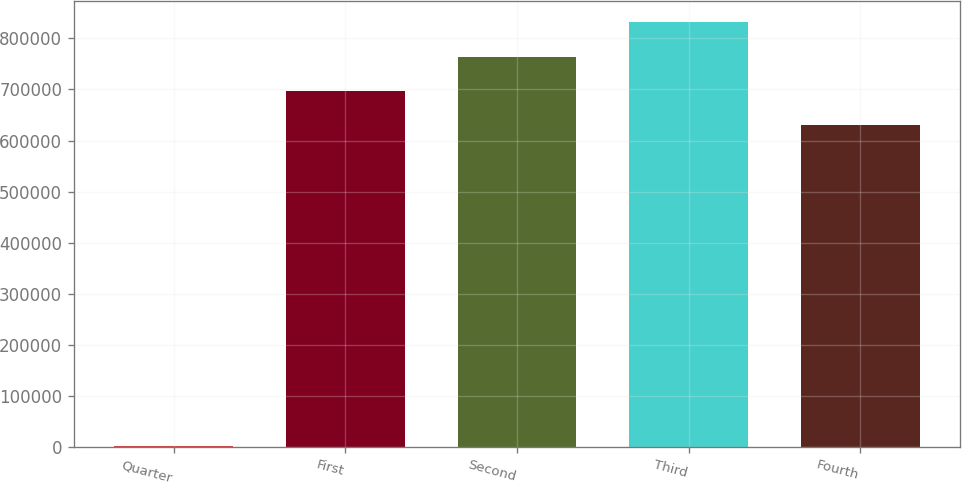Convert chart to OTSL. <chart><loc_0><loc_0><loc_500><loc_500><bar_chart><fcel>Quarter<fcel>First<fcel>Second<fcel>Third<fcel>Fourth<nl><fcel>2010<fcel>696997<fcel>764125<fcel>831252<fcel>629870<nl></chart> 